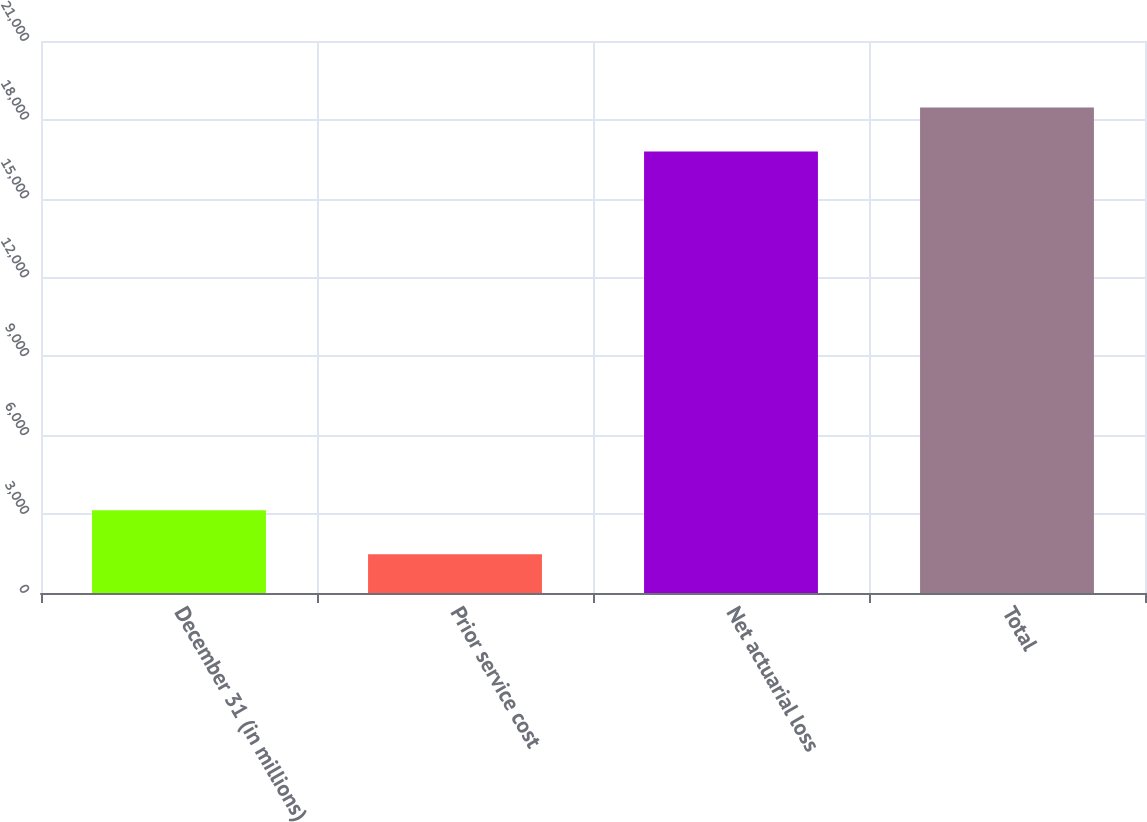Convert chart. <chart><loc_0><loc_0><loc_500><loc_500><bar_chart><fcel>December 31 (in millions)<fcel>Prior service cost<fcel>Net actuarial loss<fcel>Total<nl><fcel>3152.5<fcel>1473<fcel>16795<fcel>18474.5<nl></chart> 